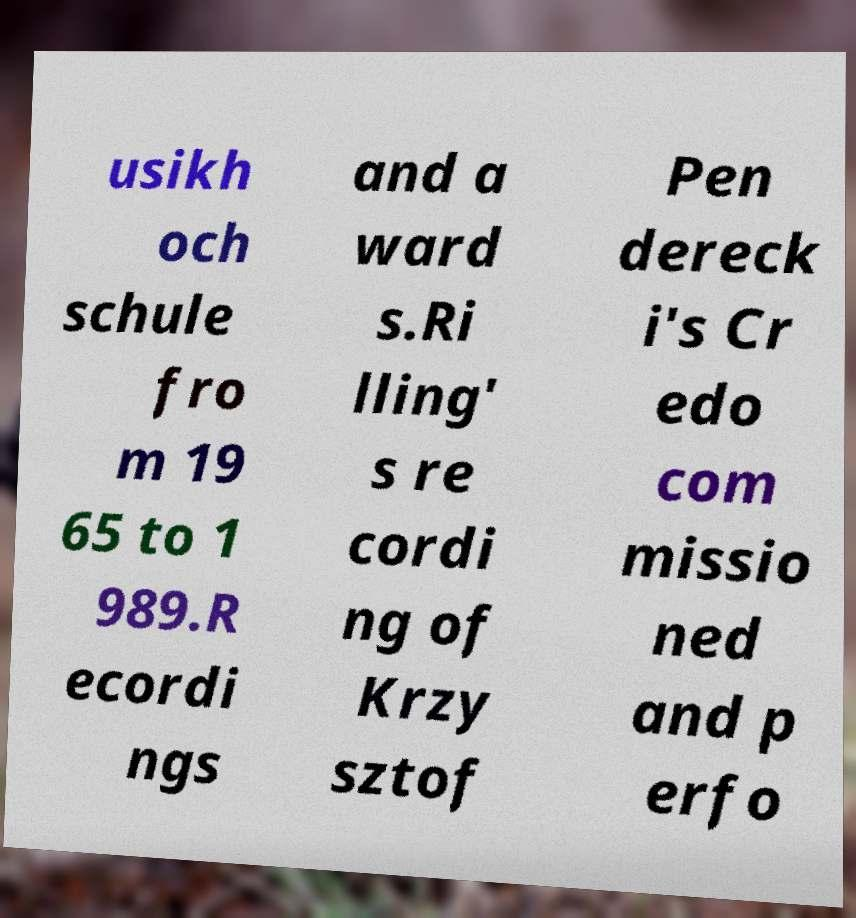What messages or text are displayed in this image? I need them in a readable, typed format. usikh och schule fro m 19 65 to 1 989.R ecordi ngs and a ward s.Ri lling' s re cordi ng of Krzy sztof Pen dereck i's Cr edo com missio ned and p erfo 